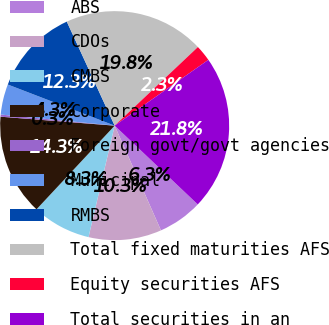<chart> <loc_0><loc_0><loc_500><loc_500><pie_chart><fcel>ABS<fcel>CDOs<fcel>CMBS<fcel>Corporate<fcel>Foreign govt/govt agencies<fcel>Municipal<fcel>RMBS<fcel>Total fixed maturities AFS<fcel>Equity securities AFS<fcel>Total securities in an<nl><fcel>6.3%<fcel>10.29%<fcel>8.29%<fcel>14.29%<fcel>0.3%<fcel>4.3%<fcel>12.29%<fcel>19.82%<fcel>2.3%<fcel>21.82%<nl></chart> 